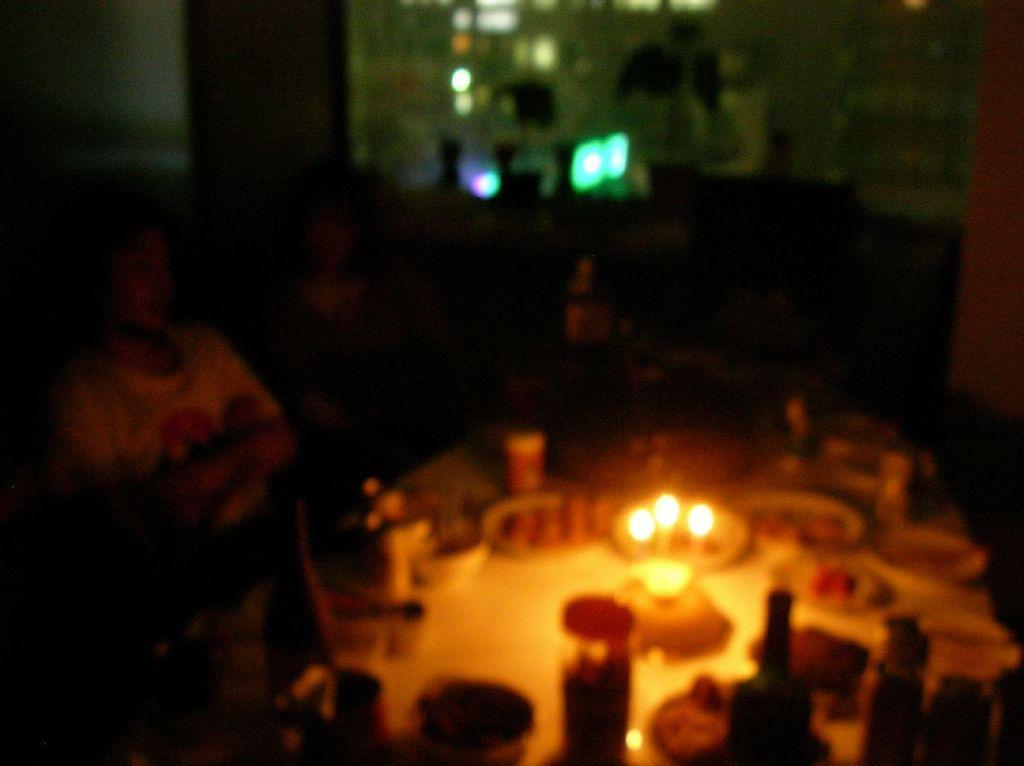Could you give a brief overview of what you see in this image? In this picture I can see few people seated and I can see food in the bowls and I can see glasses, bottles and few candles on the table and the picture is taken in the dark. 